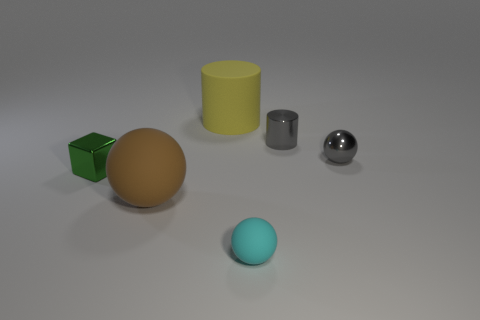What size is the ball that is both left of the shiny ball and behind the cyan rubber object?
Provide a succinct answer. Large. Is there anything else of the same color as the large rubber cylinder?
Ensure brevity in your answer.  No. What size is the shiny thing that is behind the ball behind the big sphere?
Keep it short and to the point. Small. There is a matte thing that is in front of the gray cylinder and behind the cyan rubber thing; what is its color?
Provide a succinct answer. Brown. What number of other things are the same size as the brown sphere?
Offer a terse response. 1. There is a brown rubber thing; does it have the same size as the rubber object behind the metallic cube?
Your answer should be very brief. Yes. There is another rubber thing that is the same size as the yellow object; what is its color?
Keep it short and to the point. Brown. How big is the yellow matte object?
Your response must be concise. Large. Is the material of the cylinder behind the tiny cylinder the same as the big brown sphere?
Your response must be concise. Yes. Do the tiny cyan object and the small green metal object have the same shape?
Offer a very short reply. No. 